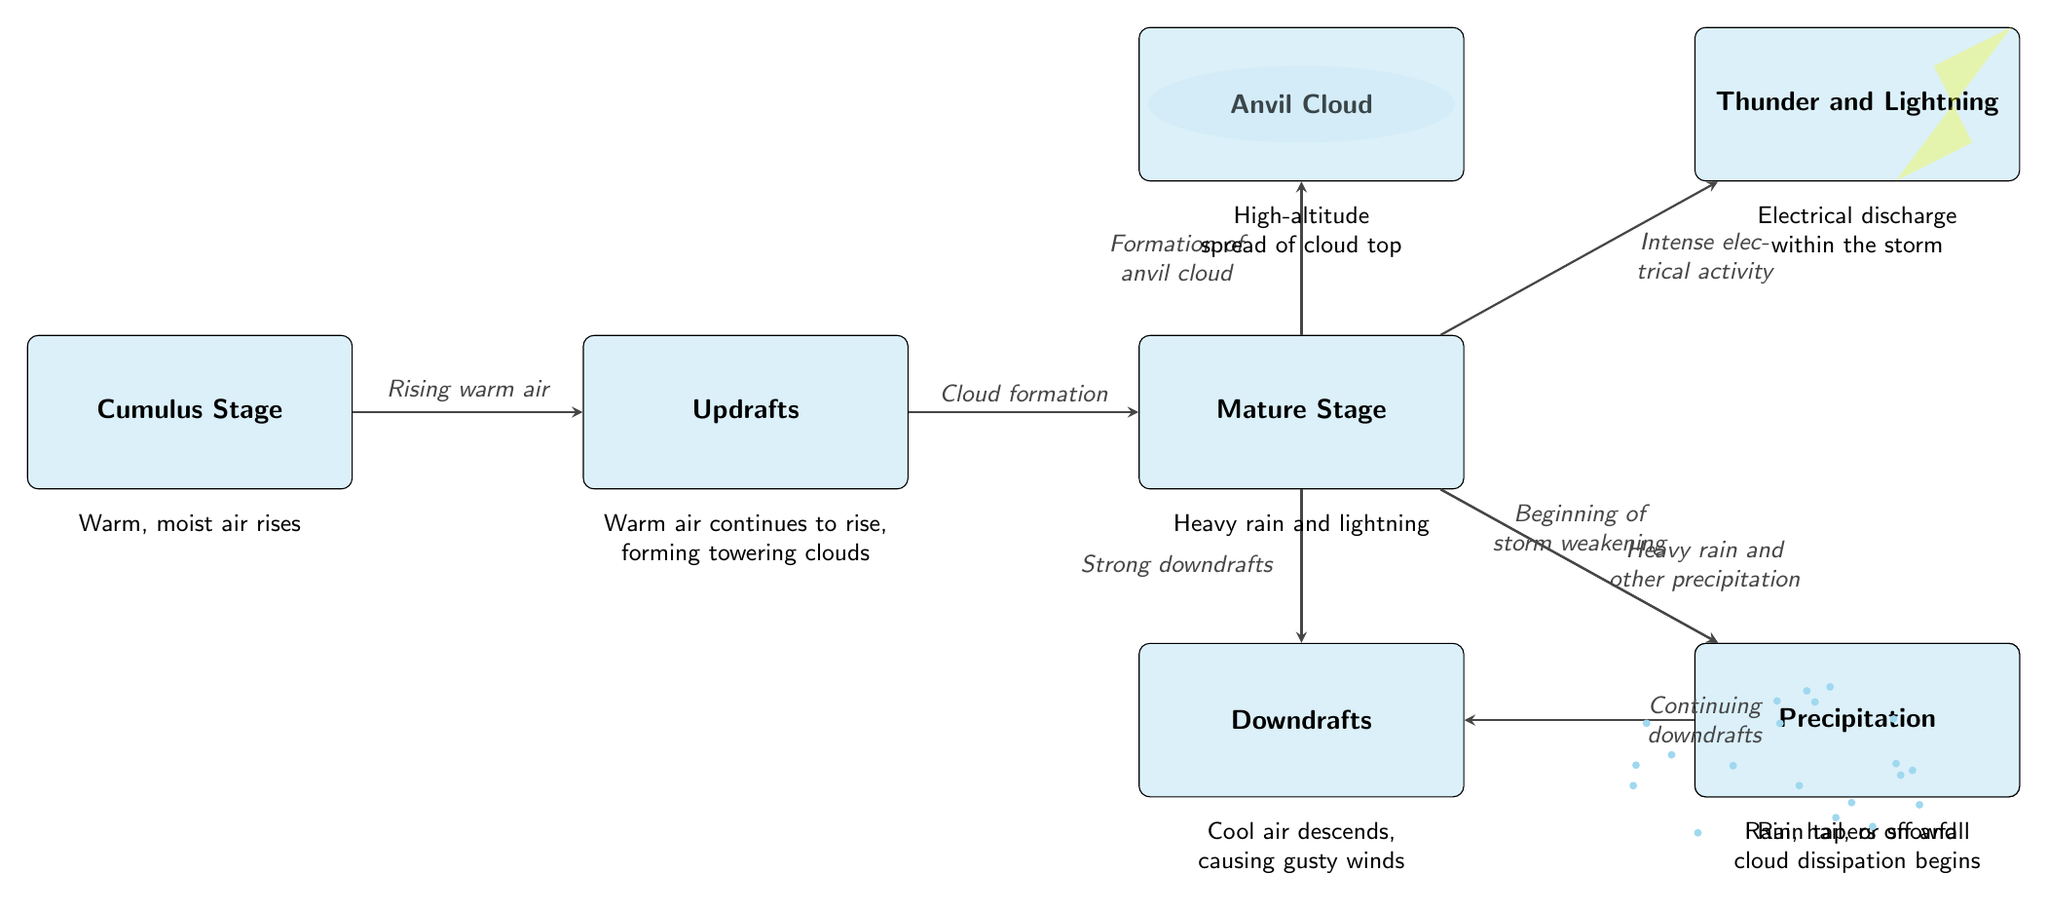What is the first stage of a thunderstorm? The diagram starts with the "Cumulus Stage," indicating it's the initial phase in the lifecycle of a thunderstorm.
Answer: Cumulus Stage How many main stages are there in the thunderstorm lifecycle? By counting the nodes in the diagram, we see there are three main stages: Cumulus Stage, Mature Stage, and Dissipating Stage.
Answer: Three What occurs after the Mature Stage? The diagram shows an arrow leading from the "Mature Stage" to the "Dissipating Stage," which indicates that the dissipation occurs immediately after maturity.
Answer: Dissipating Stage What phenomenon is associated with the Mature Stage? The "Mature Stage" node has connections to both "Thunder and Lightning" and "Precipitation," suggesting these events occur during this phase.
Answer: Thunder and Lightning What causes the development of an Anvil Cloud? The "Mature Stage" node points to the "Anvil Cloud," which signifies that it forms due to the strong updrafts and conditions present during that stage.
Answer: Formation of anvil cloud In what stage does heavy rain occur? The "Mature Stage" is depicted with arrows pointing to "Precipitation," which indicates that heavy rain is characteristic of that stage.
Answer: Mature Stage What leads to the continuing downdrafts in the Dissipating Stage? The flowchart indicates that the continuing downdrafts are a result of processes in the "Dissipating Stage," leading to the ongoing cooling and descent of air.
Answer: Continuing downdrafts What type of weather event does the Diagram illustrate? The diagram provides a structured view of the thunderstorm lifecycle, highlighting features such as updrafts, precipitation, and thunder - typical of thunderstorms.
Answer: Thunderstorm What type of cloud is created at the top of the thunderstorm? The diagram directly associates the "Mature Stage" with the creation of an "Anvil Cloud" at its peak, resulting from rising air.
Answer: Anvil Cloud 